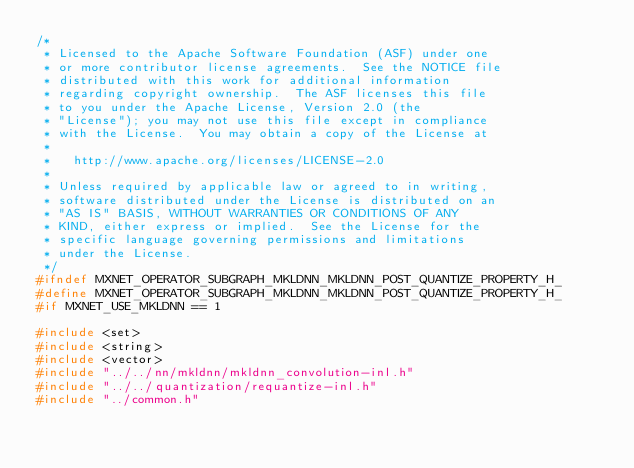<code> <loc_0><loc_0><loc_500><loc_500><_C_>/*
 * Licensed to the Apache Software Foundation (ASF) under one
 * or more contributor license agreements.  See the NOTICE file
 * distributed with this work for additional information
 * regarding copyright ownership.  The ASF licenses this file
 * to you under the Apache License, Version 2.0 (the
 * "License"); you may not use this file except in compliance
 * with the License.  You may obtain a copy of the License at
 *
 *   http://www.apache.org/licenses/LICENSE-2.0
 *
 * Unless required by applicable law or agreed to in writing,
 * software distributed under the License is distributed on an
 * "AS IS" BASIS, WITHOUT WARRANTIES OR CONDITIONS OF ANY
 * KIND, either express or implied.  See the License for the
 * specific language governing permissions and limitations
 * under the License.
 */
#ifndef MXNET_OPERATOR_SUBGRAPH_MKLDNN_MKLDNN_POST_QUANTIZE_PROPERTY_H_
#define MXNET_OPERATOR_SUBGRAPH_MKLDNN_MKLDNN_POST_QUANTIZE_PROPERTY_H_
#if MXNET_USE_MKLDNN == 1

#include <set>
#include <string>
#include <vector>
#include "../../nn/mkldnn/mkldnn_convolution-inl.h"
#include "../../quantization/requantize-inl.h"
#include "../common.h"</code> 